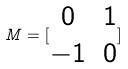Convert formula to latex. <formula><loc_0><loc_0><loc_500><loc_500>M = [ \begin{matrix} 0 & 1 \\ - 1 & 0 \end{matrix} ]</formula> 